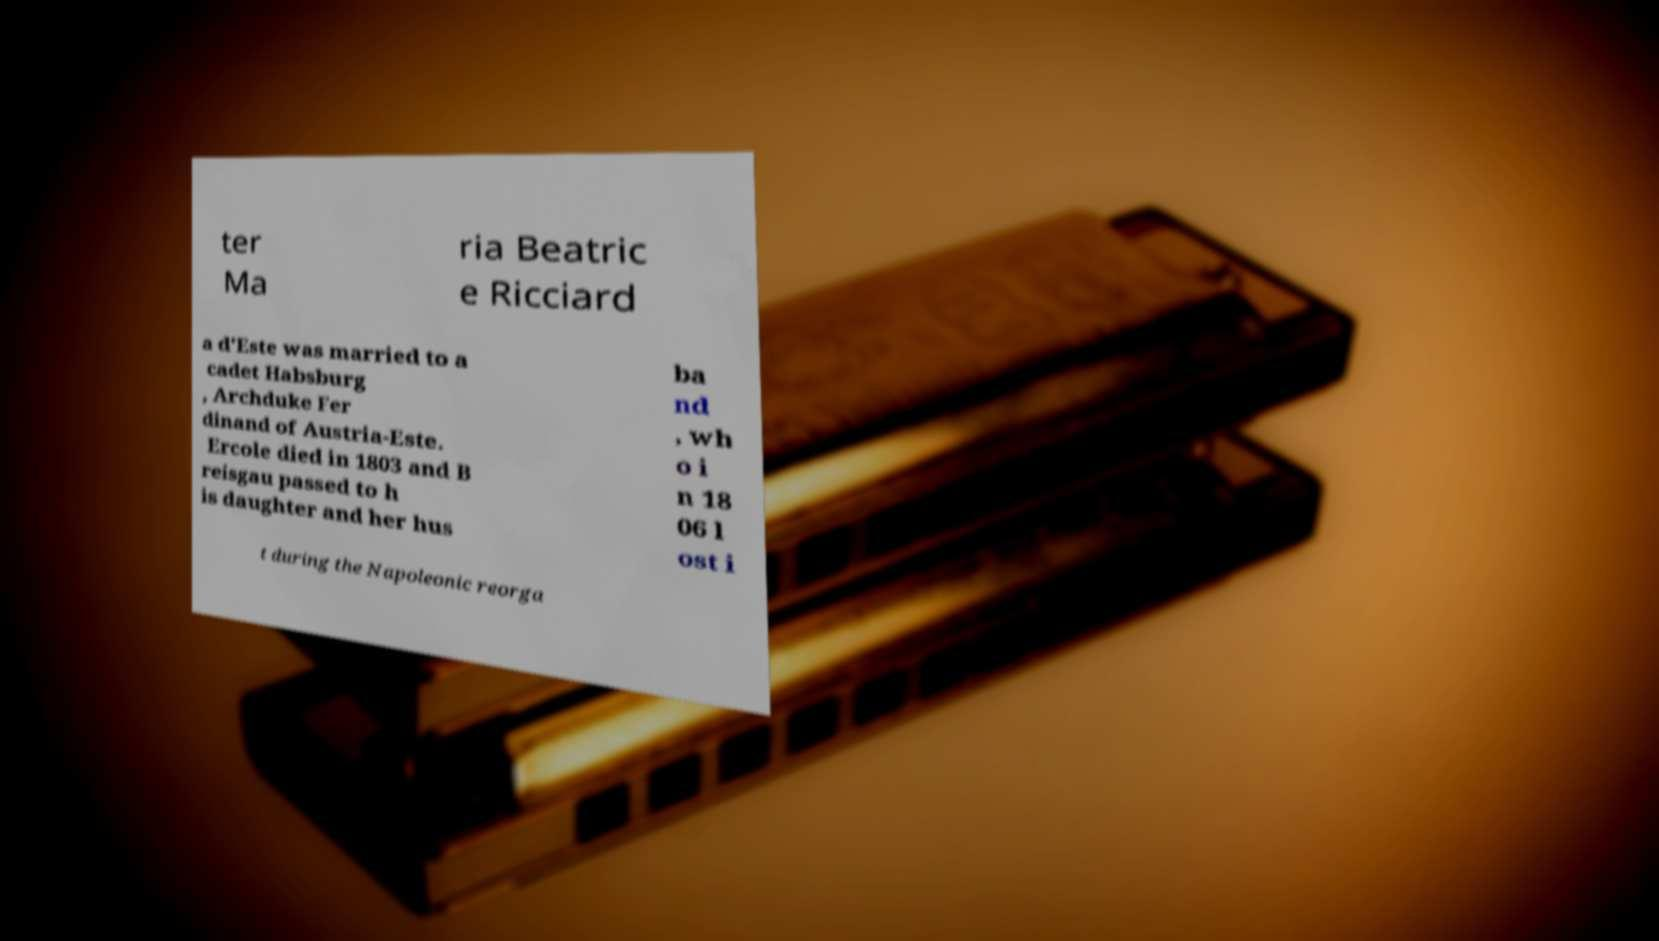What messages or text are displayed in this image? I need them in a readable, typed format. ter Ma ria Beatric e Ricciard a d'Este was married to a cadet Habsburg , Archduke Fer dinand of Austria-Este. Ercole died in 1803 and B reisgau passed to h is daughter and her hus ba nd , wh o i n 18 06 l ost i t during the Napoleonic reorga 